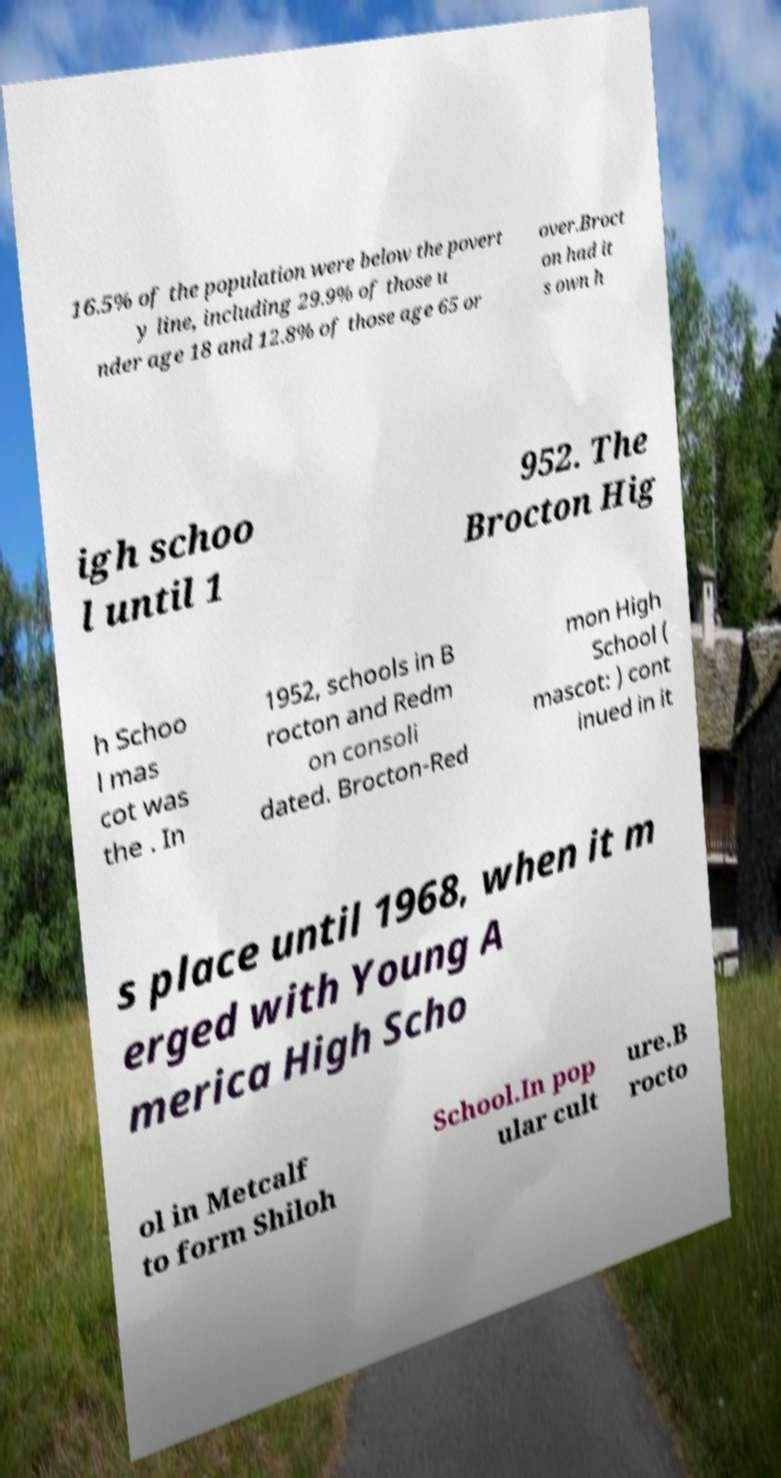I need the written content from this picture converted into text. Can you do that? 16.5% of the population were below the povert y line, including 29.9% of those u nder age 18 and 12.8% of those age 65 or over.Broct on had it s own h igh schoo l until 1 952. The Brocton Hig h Schoo l mas cot was the . In 1952, schools in B rocton and Redm on consoli dated. Brocton-Red mon High School ( mascot: ) cont inued in it s place until 1968, when it m erged with Young A merica High Scho ol in Metcalf to form Shiloh School.In pop ular cult ure.B rocto 